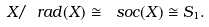<formula> <loc_0><loc_0><loc_500><loc_500>X / \ r a d ( X ) \cong \ s o c ( X ) \cong S _ { 1 } .</formula> 